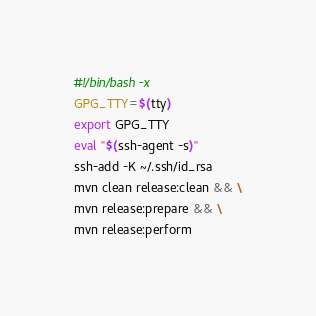Convert code to text. <code><loc_0><loc_0><loc_500><loc_500><_Bash_>#!/bin/bash -x
GPG_TTY=$(tty)
export GPG_TTY
eval "$(ssh-agent -s)"
ssh-add -K ~/.ssh/id_rsa
mvn clean release:clean && \
mvn release:prepare && \
mvn release:perform
</code> 